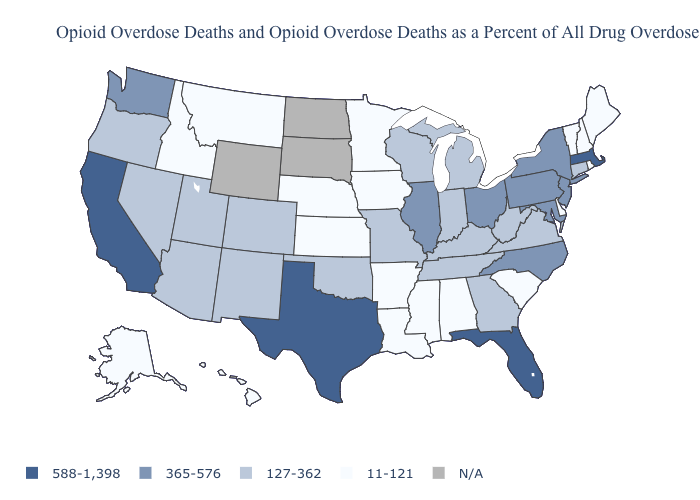Which states have the highest value in the USA?
Give a very brief answer. California, Florida, Massachusetts, Texas. What is the highest value in the USA?
Be succinct. 588-1,398. What is the highest value in states that border North Carolina?
Keep it brief. 127-362. What is the value of Montana?
Answer briefly. 11-121. Name the states that have a value in the range 365-576?
Quick response, please. Illinois, Maryland, New Jersey, New York, North Carolina, Ohio, Pennsylvania, Washington. Which states have the lowest value in the USA?
Keep it brief. Alabama, Alaska, Arkansas, Delaware, Hawaii, Idaho, Iowa, Kansas, Louisiana, Maine, Minnesota, Mississippi, Montana, Nebraska, New Hampshire, Rhode Island, South Carolina, Vermont. What is the value of California?
Keep it brief. 588-1,398. Does Washington have the lowest value in the USA?
Give a very brief answer. No. Which states have the lowest value in the MidWest?
Answer briefly. Iowa, Kansas, Minnesota, Nebraska. What is the value of Idaho?
Keep it brief. 11-121. Does Florida have the highest value in the South?
Be succinct. Yes. What is the value of Massachusetts?
Short answer required. 588-1,398. Which states have the lowest value in the USA?
Write a very short answer. Alabama, Alaska, Arkansas, Delaware, Hawaii, Idaho, Iowa, Kansas, Louisiana, Maine, Minnesota, Mississippi, Montana, Nebraska, New Hampshire, Rhode Island, South Carolina, Vermont. Among the states that border North Carolina , which have the lowest value?
Be succinct. South Carolina. 